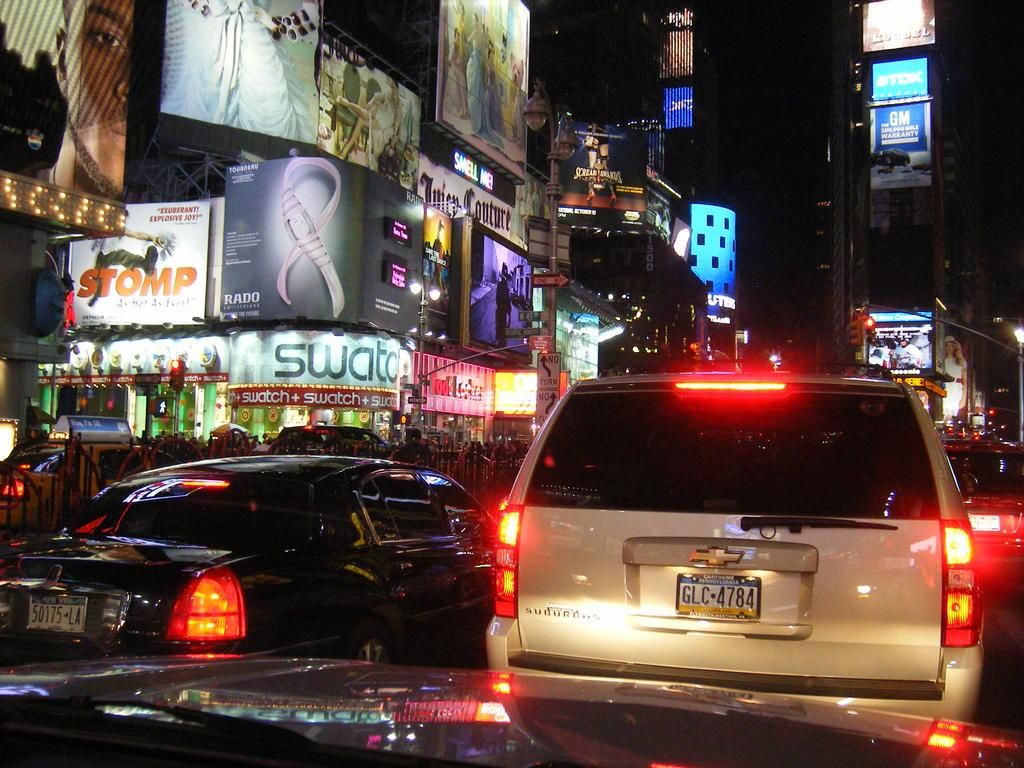<image>
Describe the image concisely. Chevy truck with license GLC4784 stuck in night traffic. 